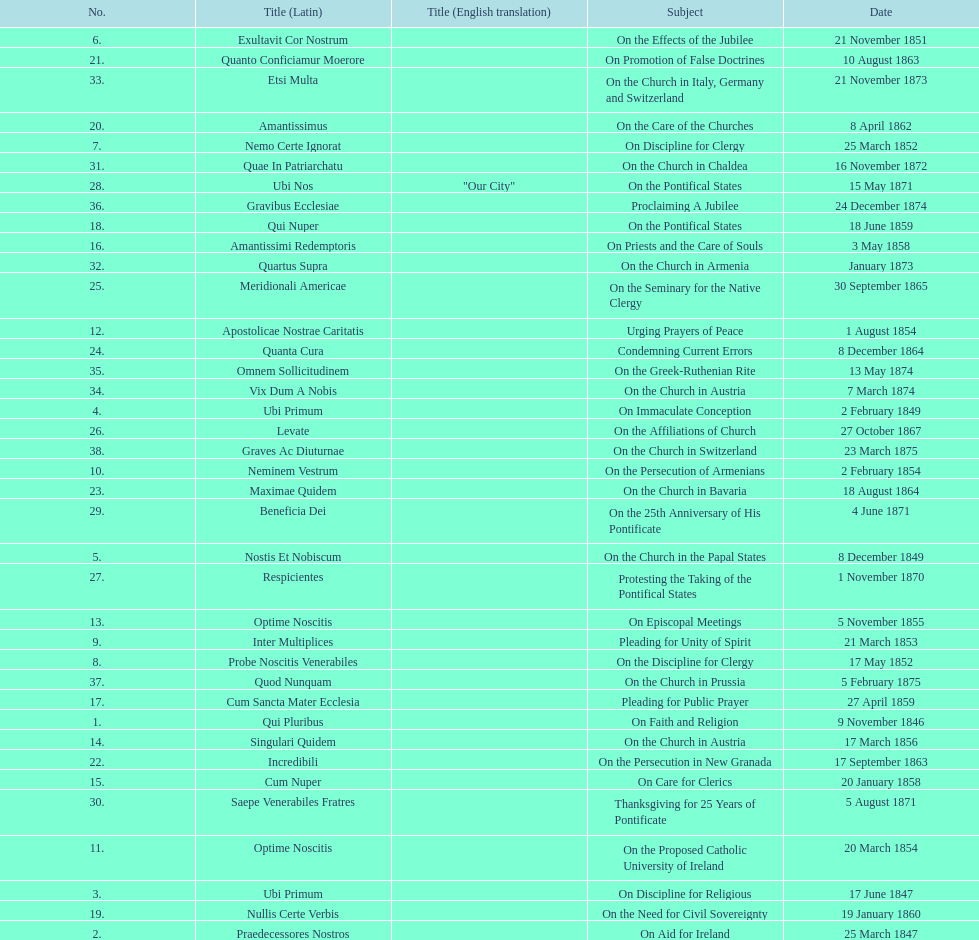Total count of encyclicals regarding churches. 11. 